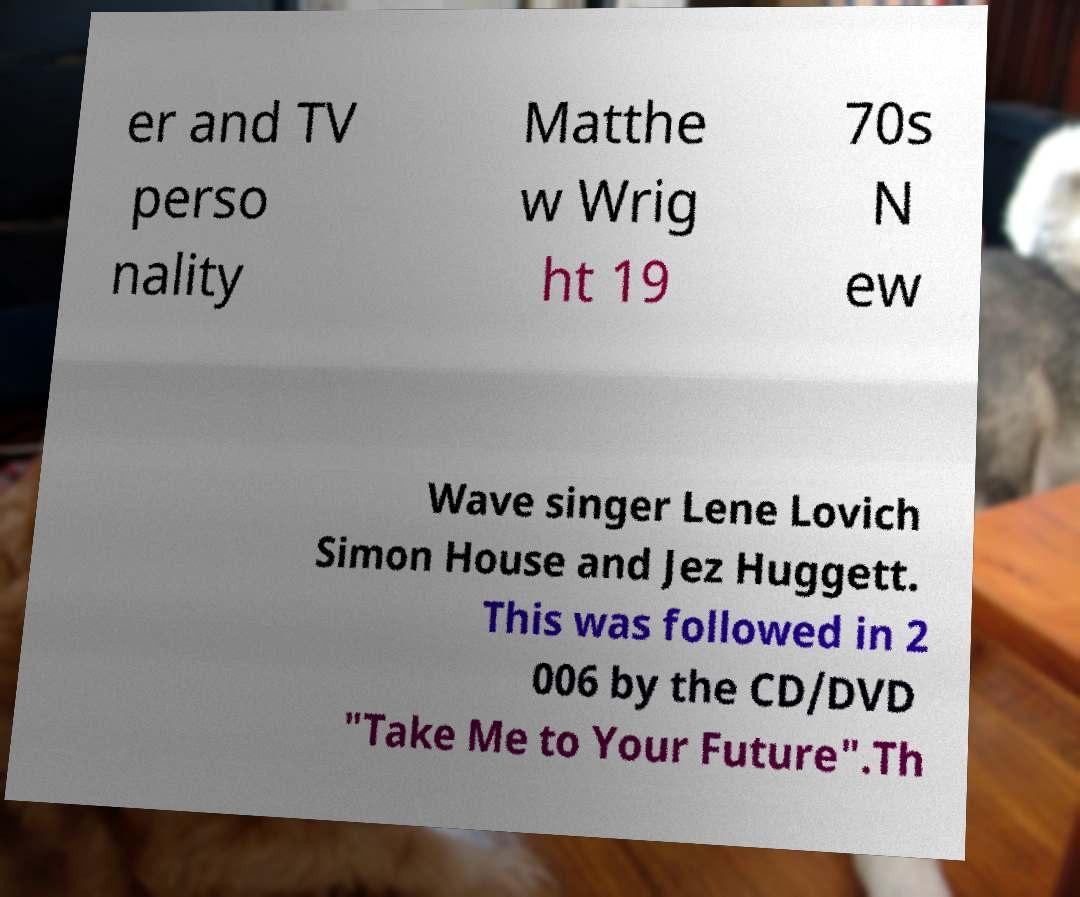Can you read and provide the text displayed in the image?This photo seems to have some interesting text. Can you extract and type it out for me? er and TV perso nality Matthe w Wrig ht 19 70s N ew Wave singer Lene Lovich Simon House and Jez Huggett. This was followed in 2 006 by the CD/DVD "Take Me to Your Future".Th 